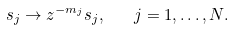<formula> <loc_0><loc_0><loc_500><loc_500>s _ { j } \to z ^ { - m _ { j } } s _ { j } , \quad j = 1 , \dots , N .</formula> 